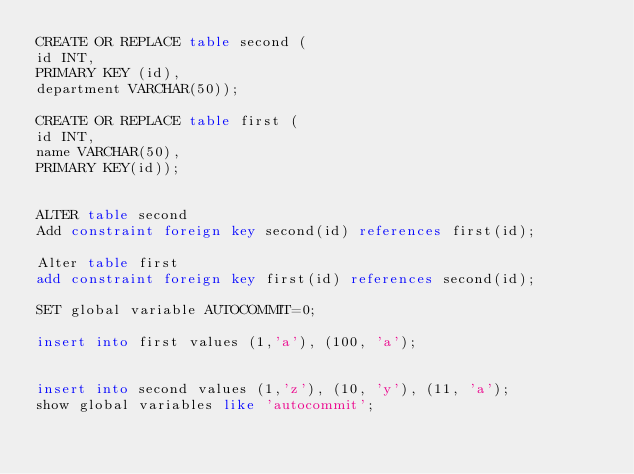<code> <loc_0><loc_0><loc_500><loc_500><_SQL_>CREATE OR REPLACE table second (
id INT,
PRIMARY KEY (id),
department VARCHAR(50));

CREATE OR REPLACE table first (
id INT,
name VARCHAR(50),
PRIMARY KEY(id));


ALTER table second
Add constraint foreign key second(id) references first(id);

Alter table first
add constraint foreign key first(id) references second(id);

SET global variable AUTOCOMMIT=0;  

insert into first values (1,'a'), (100, 'a');


insert into second values (1,'z'), (10, 'y'), (11, 'a');
show global variables like 'autocommit';


</code> 